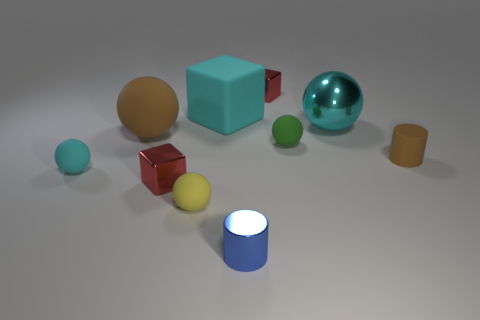There is a brown rubber object that is behind the cylinder that is behind the blue object; how many tiny rubber spheres are to the left of it?
Ensure brevity in your answer.  1. Is there any other thing that is made of the same material as the large cyan block?
Your response must be concise. Yes. Are there fewer tiny yellow matte things that are left of the big rubber sphere than blue balls?
Offer a very short reply. No. Is the rubber block the same color as the tiny rubber cylinder?
Ensure brevity in your answer.  No. What size is the green matte object that is the same shape as the yellow matte thing?
Your response must be concise. Small. What number of tiny green balls have the same material as the tiny brown object?
Your answer should be very brief. 1. Is the material of the red thing behind the tiny brown cylinder the same as the tiny green thing?
Your answer should be very brief. No. Are there an equal number of small red metallic things to the left of the small cyan ball and big brown metal blocks?
Offer a terse response. Yes. What is the size of the yellow matte ball?
Your response must be concise. Small. What material is the small object that is the same color as the big matte ball?
Provide a succinct answer. Rubber. 